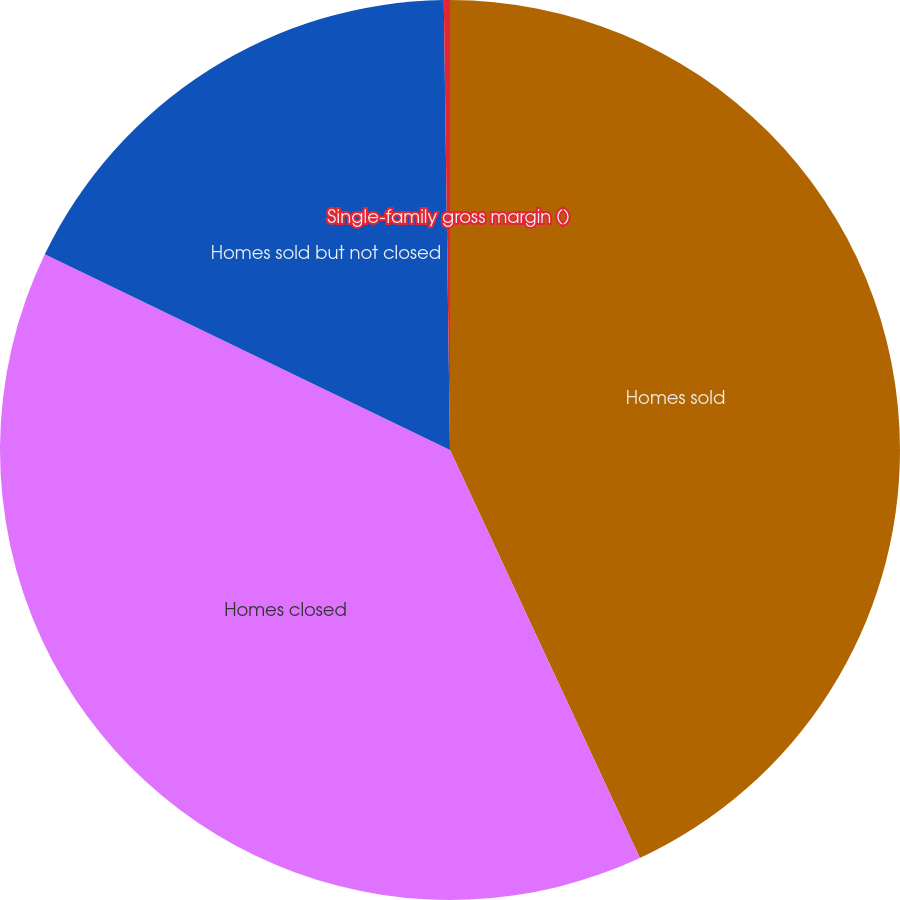<chart> <loc_0><loc_0><loc_500><loc_500><pie_chart><fcel>Homes sold<fcel>Homes closed<fcel>Homes sold but not closed<fcel>Single-family gross margin ()<nl><fcel>43.07%<fcel>39.1%<fcel>17.62%<fcel>0.22%<nl></chart> 